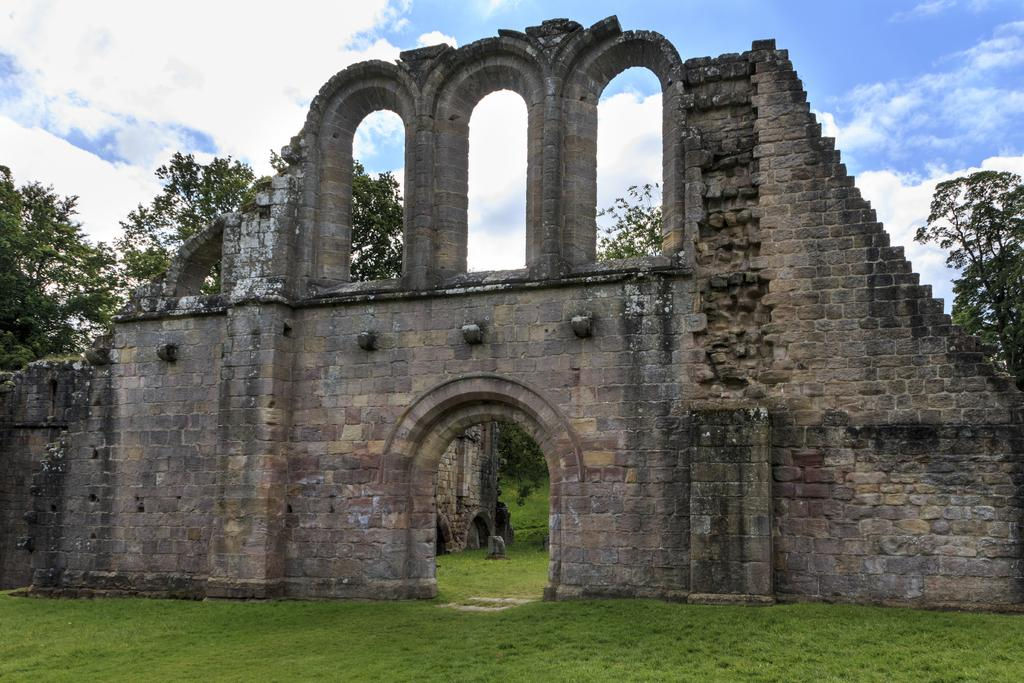What is the main structure in the image? There is a monument in the image. What type of vegetation can be seen in the image? There is grass visible in the image, as well as a group of trees. What is visible in the background of the image? The sky is visible in the image. How would you describe the weather based on the sky in the image? The sky appears to be cloudy in the image. What type of badge is the guitar wearing in the image? There is no guitar or badge present in the image. How is the coal being used in the image? There is no coal present in the image. 